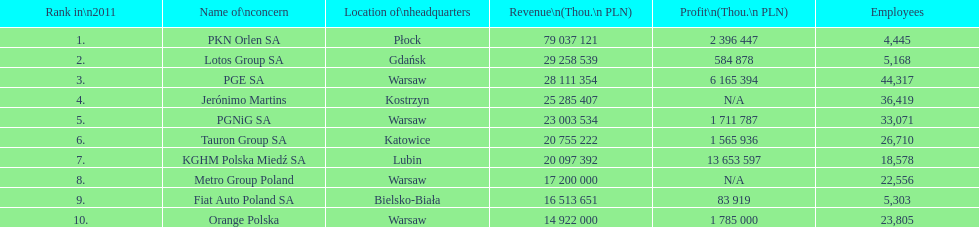What is the difference in employees for rank 1 and rank 3? 39,872 employees. 